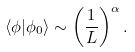<formula> <loc_0><loc_0><loc_500><loc_500>\langle \phi | \phi _ { 0 } \rangle \sim \left ( \frac { 1 } { L } \right ) ^ { \alpha } .</formula> 